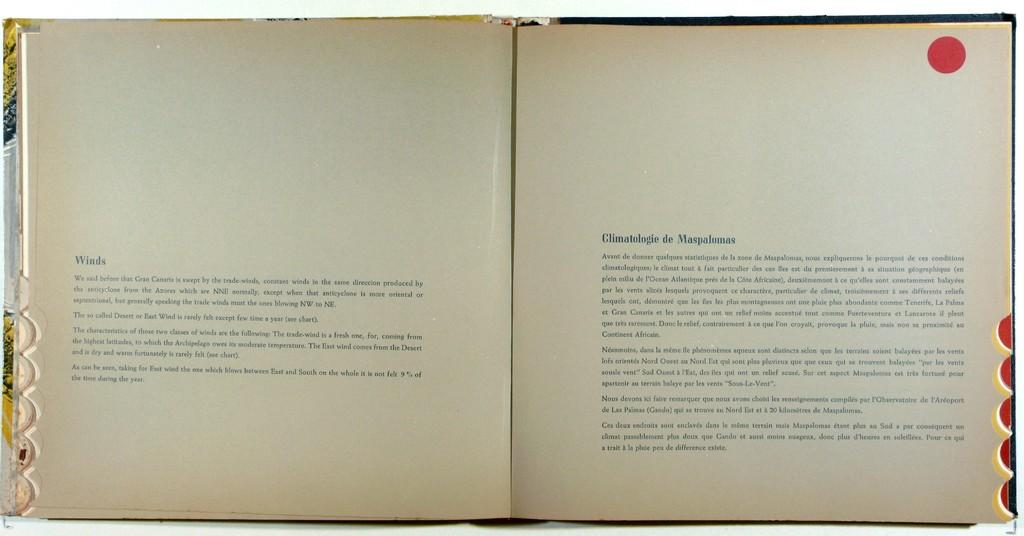What is the main object in the image? There is a book in the image. What else can be seen in the image besides the book? There are papers with text in the image. How many icicles are hanging from the book in the image? There are no icicles present in the image. What type of judge is depicted on the book in the image? There is no judge depicted on the book in the image. 